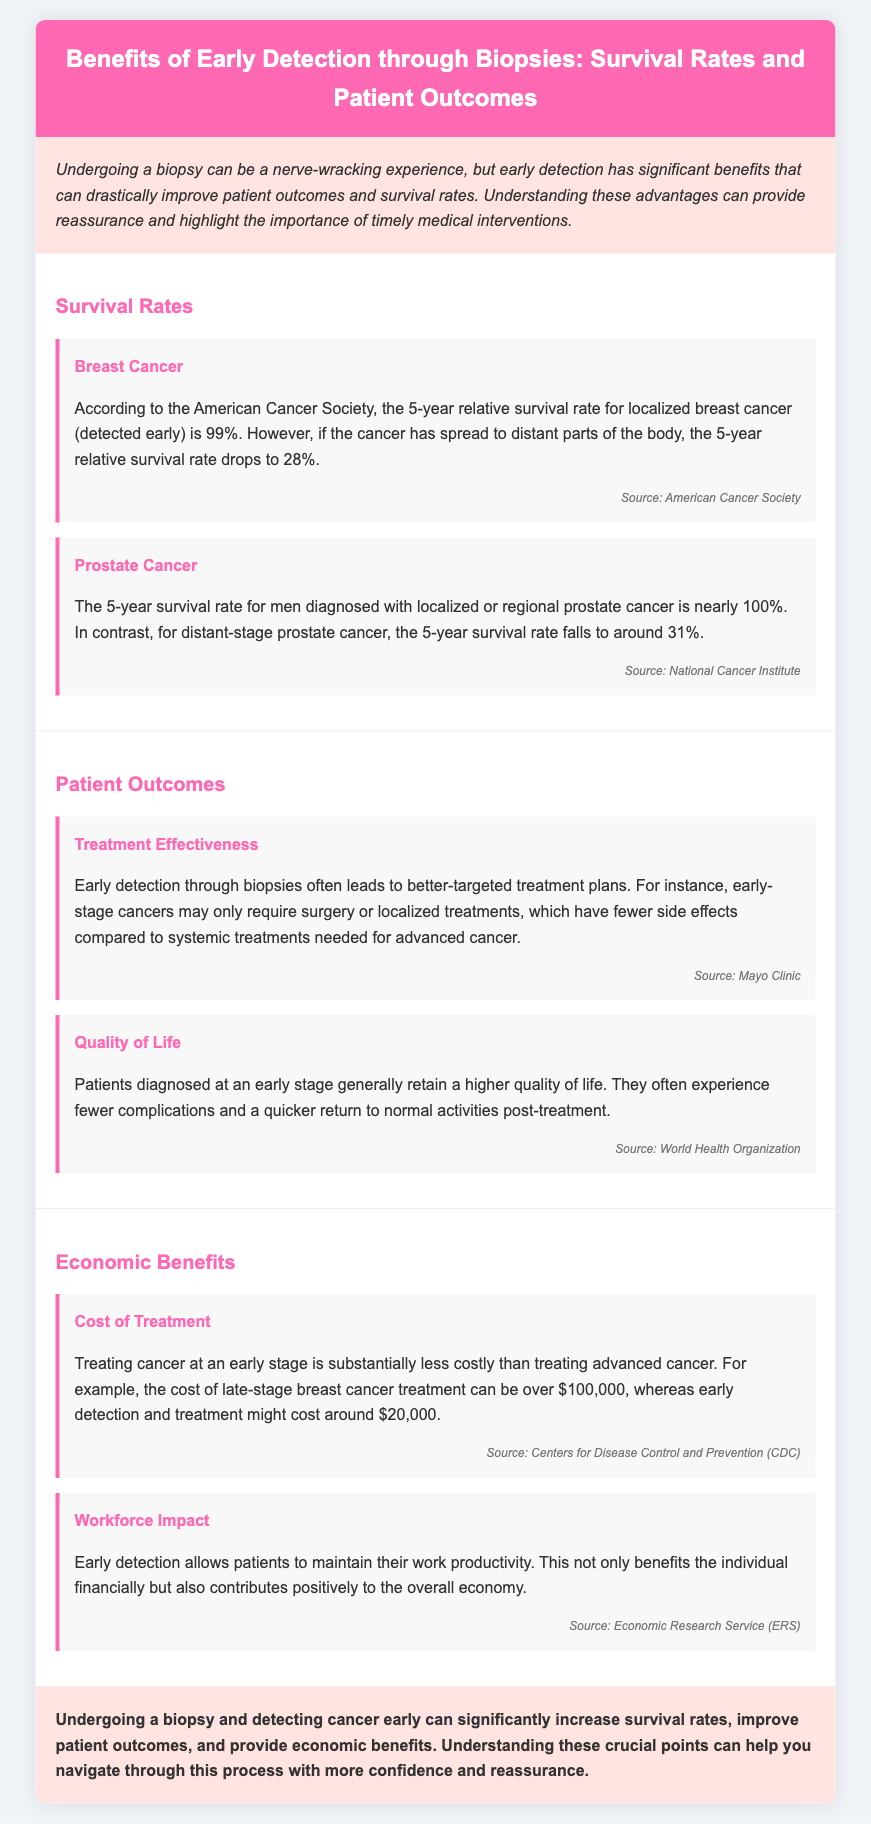What is the 5-year relative survival rate for localized breast cancer? The document states that the 5-year relative survival rate for localized breast cancer is 99%.
Answer: 99% What is the survival rate for distant-stage prostate cancer? According to the document, the 5-year survival rate for distant-stage prostate cancer is around 31%.
Answer: 31% What is one treatment option for early-stage cancers mentioned in the document? The document mentions that early-stage cancers may only require surgery or localized treatments.
Answer: Surgery What economic benefit is associated with early cancer detection? The document mentions that treating cancer at an early stage is substantially less costly compared to treating advanced cancer.
Answer: Cost-effectiveness How does early detection impact patients' quality of life? Early detection generally allows patients to retain a higher quality of life and experience fewer complications.
Answer: Higher quality of life What source provided the information on the 5-year relative survival rate for localized breast cancer? The document states that the source for this information is the American Cancer Society.
Answer: American Cancer Society What is a consequence of detecting cancer late according to the infographic? The document indicates that cost of late-stage breast cancer treatment can be over $100,000.
Answer: High treatment costs What percentage of men diagnosed with localized prostate cancer survive five years? The document notes that nearly 100% of men diagnosed with localized or regional prostate cancer survive five years.
Answer: Nearly 100% 